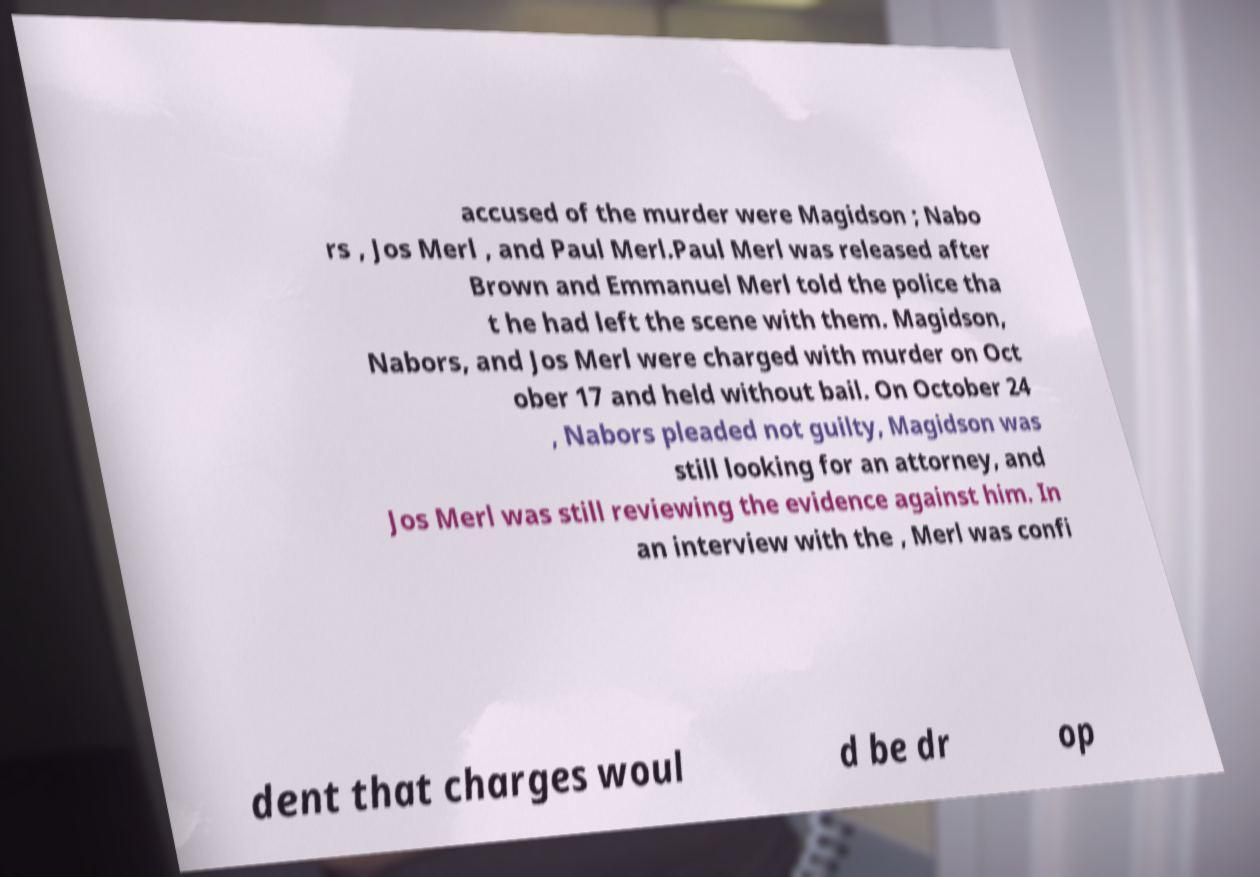Please identify and transcribe the text found in this image. accused of the murder were Magidson ; Nabo rs , Jos Merl , and Paul Merl.Paul Merl was released after Brown and Emmanuel Merl told the police tha t he had left the scene with them. Magidson, Nabors, and Jos Merl were charged with murder on Oct ober 17 and held without bail. On October 24 , Nabors pleaded not guilty, Magidson was still looking for an attorney, and Jos Merl was still reviewing the evidence against him. In an interview with the , Merl was confi dent that charges woul d be dr op 